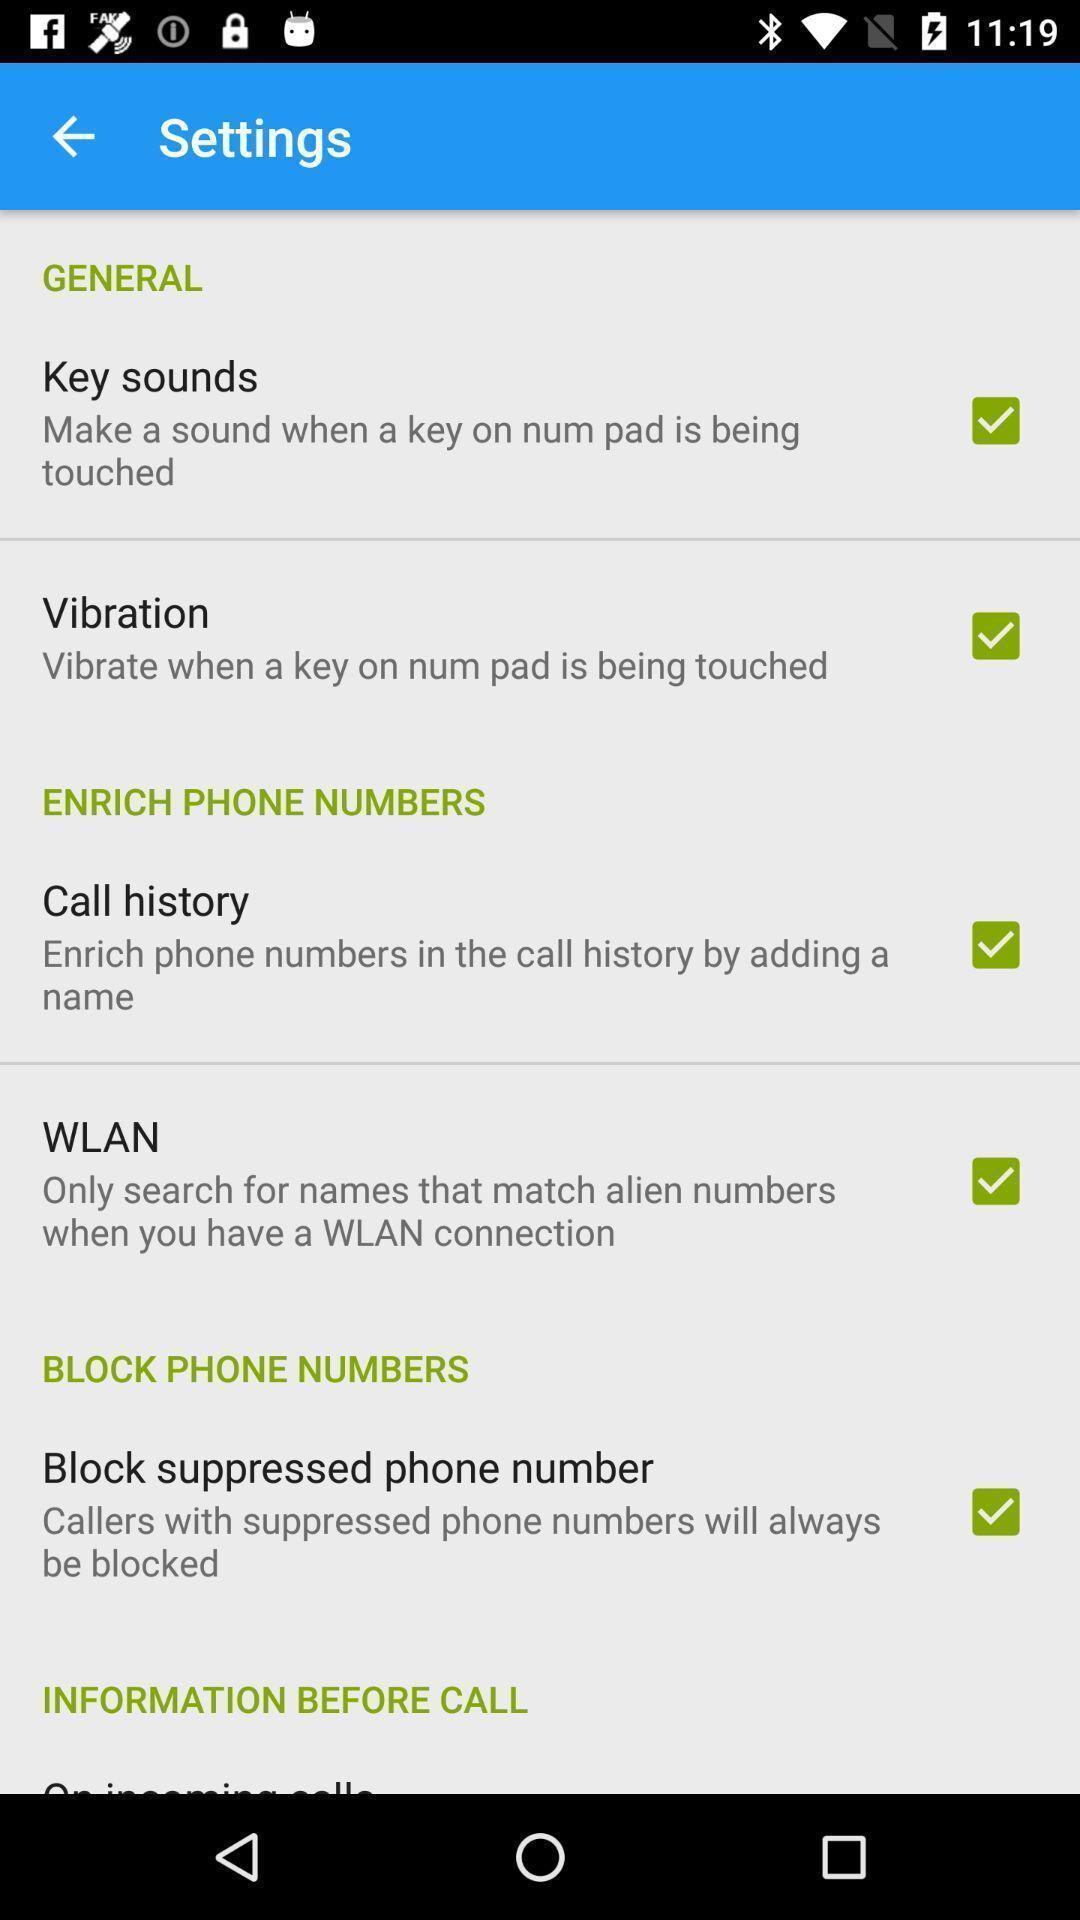Give me a narrative description of this picture. Settings tab in the application with different options. 